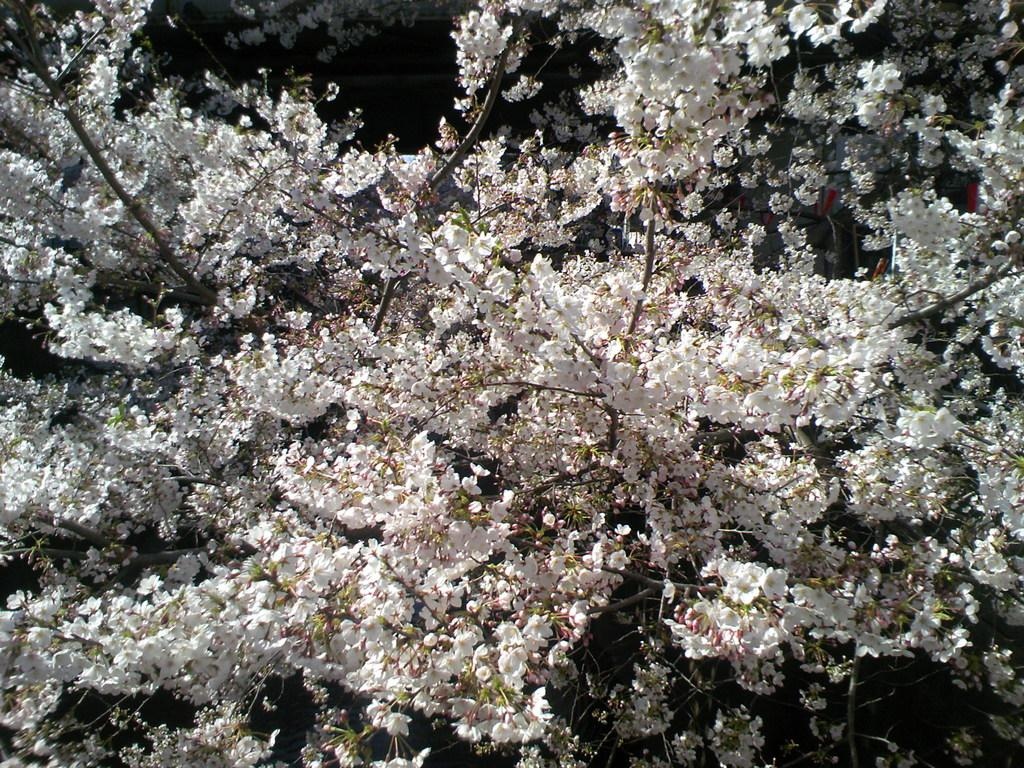What type of flowers are present in the image? There are beautiful white flowers in the image. Where are the flowers located on the tree? The flowers are on the branches of a tree. What type of end can be seen on the tree in the image? There is no end present on the tree in the image; it is a living tree with branches and flowers. Is there a doctor visible in the image? There is no doctor present in the image; it features a tree with beautiful white flowers on its branches. 